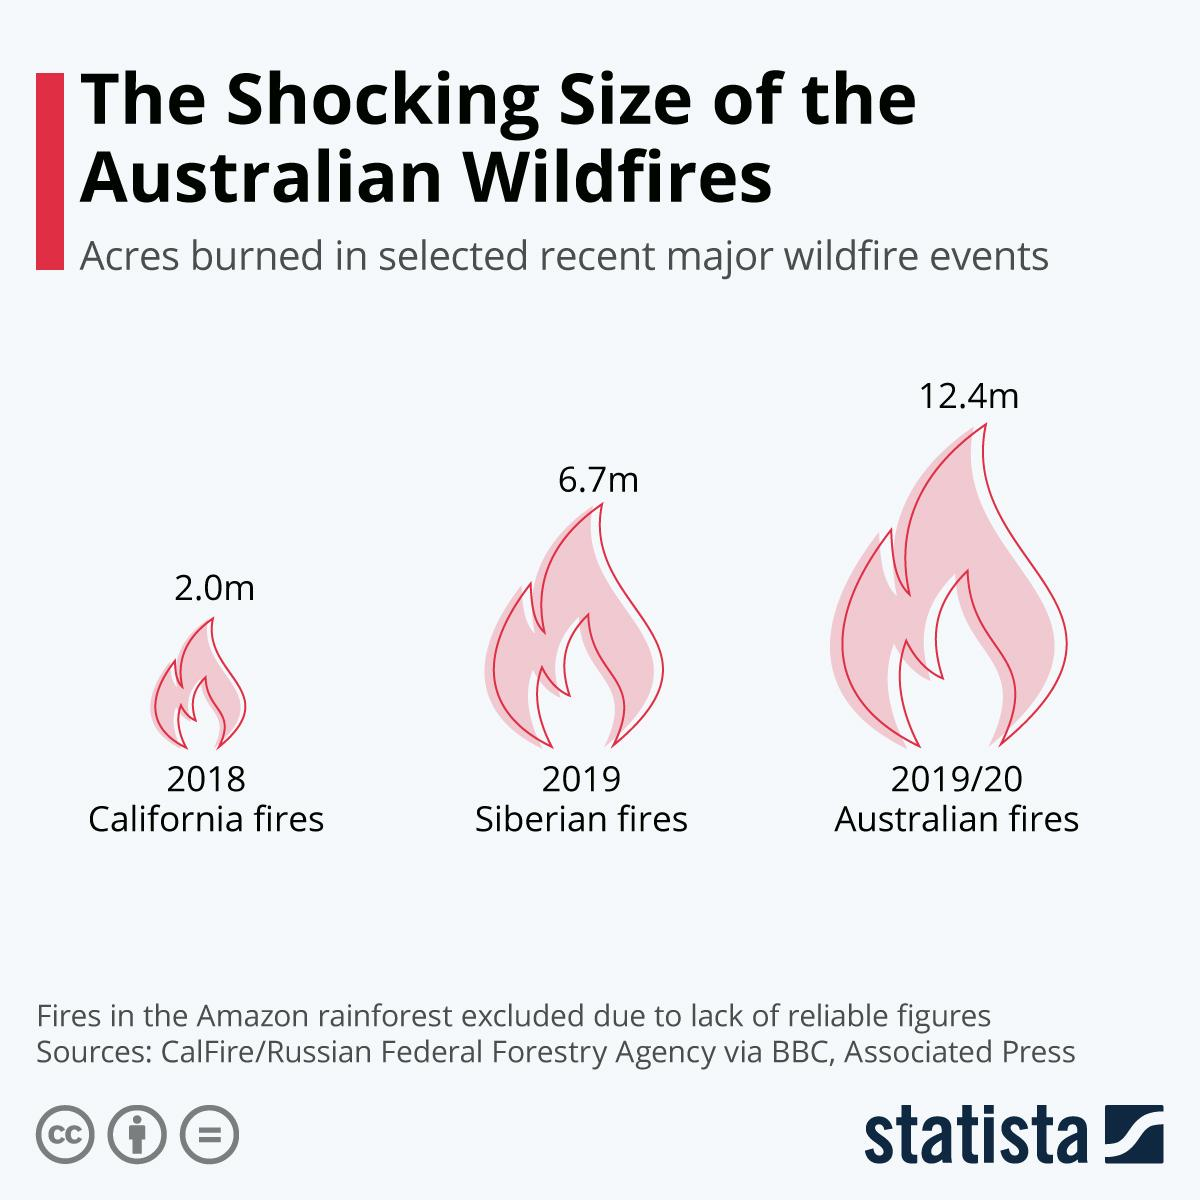Indicate a few pertinent items in this graphic. In 2018, a total of approximately 2.0 million acres were burned in the state of California. In the 2019/2020 fire season in Australia, a total of approximately 12.4 million acres were burned. The number of acres burned in the Siberian fires in 2019 was 6.7 million. 